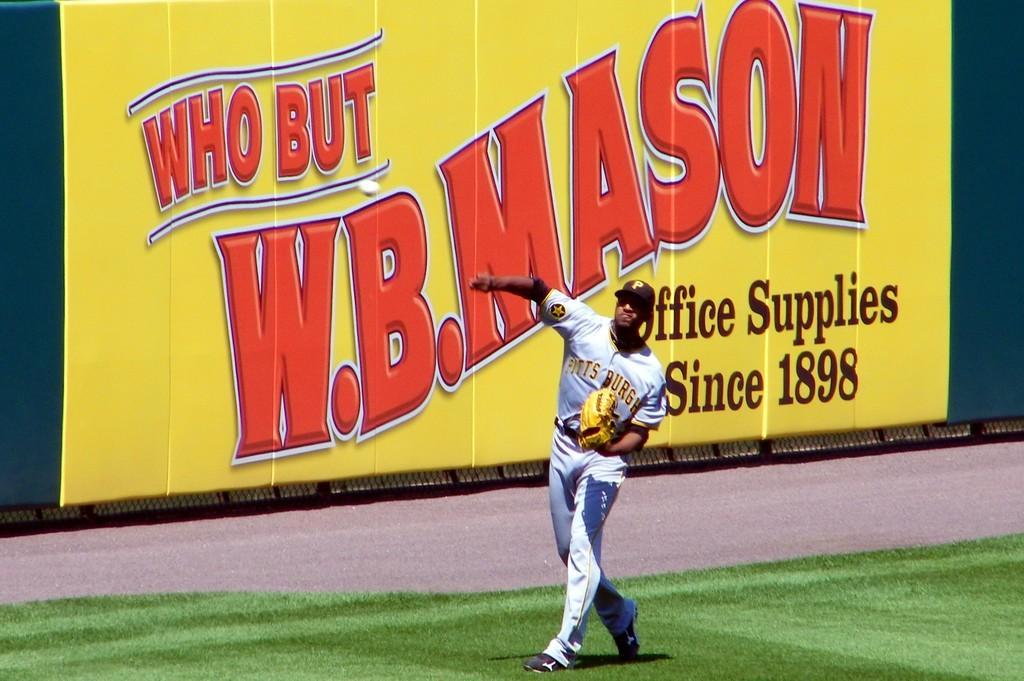<image>
Write a terse but informative summary of the picture. W.B. Mason sign is behind a baseball player on the field. 